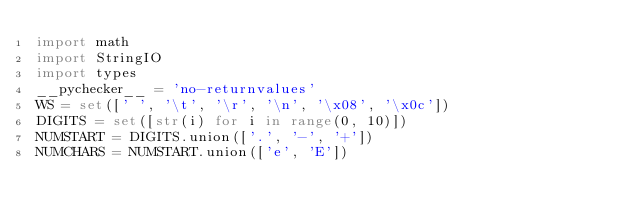Convert code to text. <code><loc_0><loc_0><loc_500><loc_500><_Python_>import math
import StringIO
import types
__pychecker__ = 'no-returnvalues'
WS = set([' ', '\t', '\r', '\n', '\x08', '\x0c'])
DIGITS = set([str(i) for i in range(0, 10)])
NUMSTART = DIGITS.union(['.', '-', '+'])
NUMCHARS = NUMSTART.union(['e', 'E'])</code> 